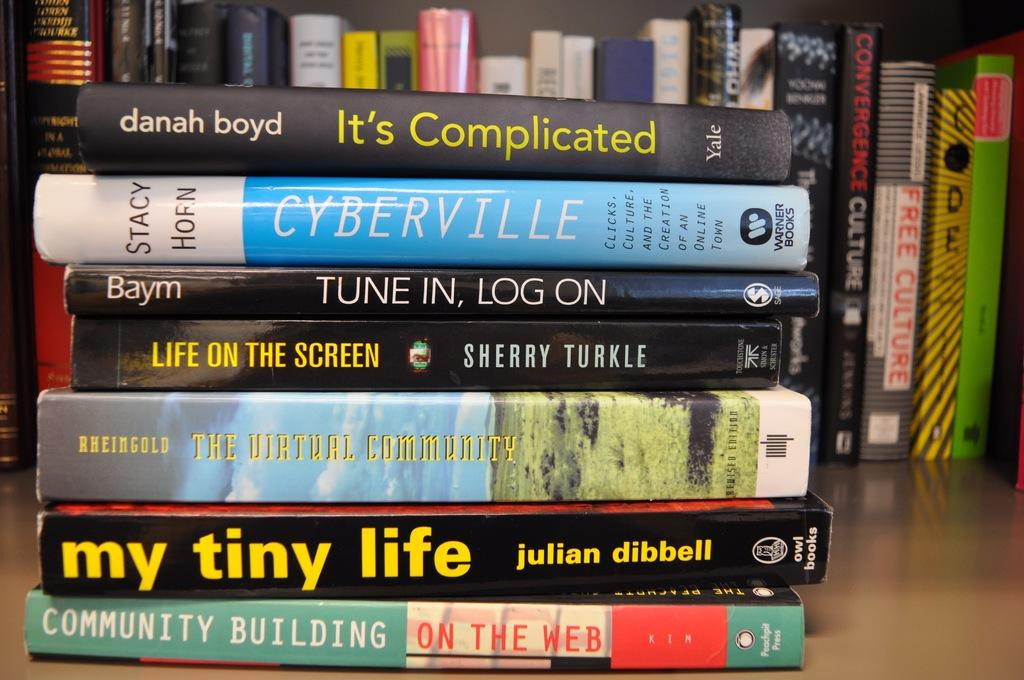<image>
Present a compact description of the photo's key features. A pile of books are on a shelf and the book on top is called It's Complicated by Danah Boyd. 